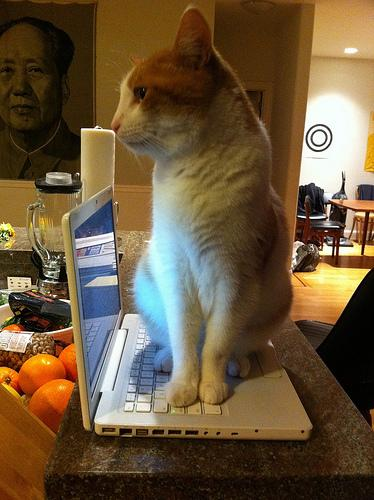Examine the image and state the emotions it evokes. The image evokes a sense of curiosity and playfulness due to the cat's interaction with the laptop and its charming appearance. Identify the main object within the image and describe its appearances. An orange and white cat with gold eyes is sitting on an open, white laptop that is placed on a marble counter. Based on the image, what might the person who took this picture be doing or thinking? The person taking this picture might be observing the cat's amusing behavior and its interaction with different objects in the kitchen, while possibly capturing a candid moment with a sense of humor. Describe the setting and theme of the image. The image is set in a kitchen with various objects such as a laptop, oranges, and a blender on a brown granite counter top, and a wooden table with chairs in the background. Analyze the quality of the image based on the complexity and detail of the objects depicted. The image has a moderate level of quality, with a variety of objects that have specific details such as shapes, colors, and sizes, but not many intricate features. Describe any unique features, if any, of the cat's appearance in the image. The cat has unique features such as its orange and white fur, gold eyes, and white whiskers, making it an attractive and distinctive subject in the image. What is the interaction between the cat and the laptop in the image? The cat is sitting on the open, white laptop, possibly causing a reflection of light from the laptop on its fur. Describe a complex interaction between two different objects in the image. The cat, sitting on the open laptop, may be attracted to the light reflection from the laptop screen, which in turn causes the reflection of the light from the laptop on the cat's fur. 